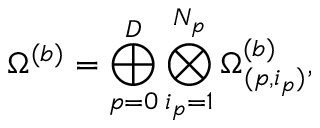<formula> <loc_0><loc_0><loc_500><loc_500>\Omega ^ { ( b ) } = \bigoplus _ { p = 0 } ^ { D } \bigotimes _ { i _ { p } = 1 } ^ { N _ { p } } \Omega _ { ( p , i _ { p } ) } ^ { ( b ) } ,</formula> 